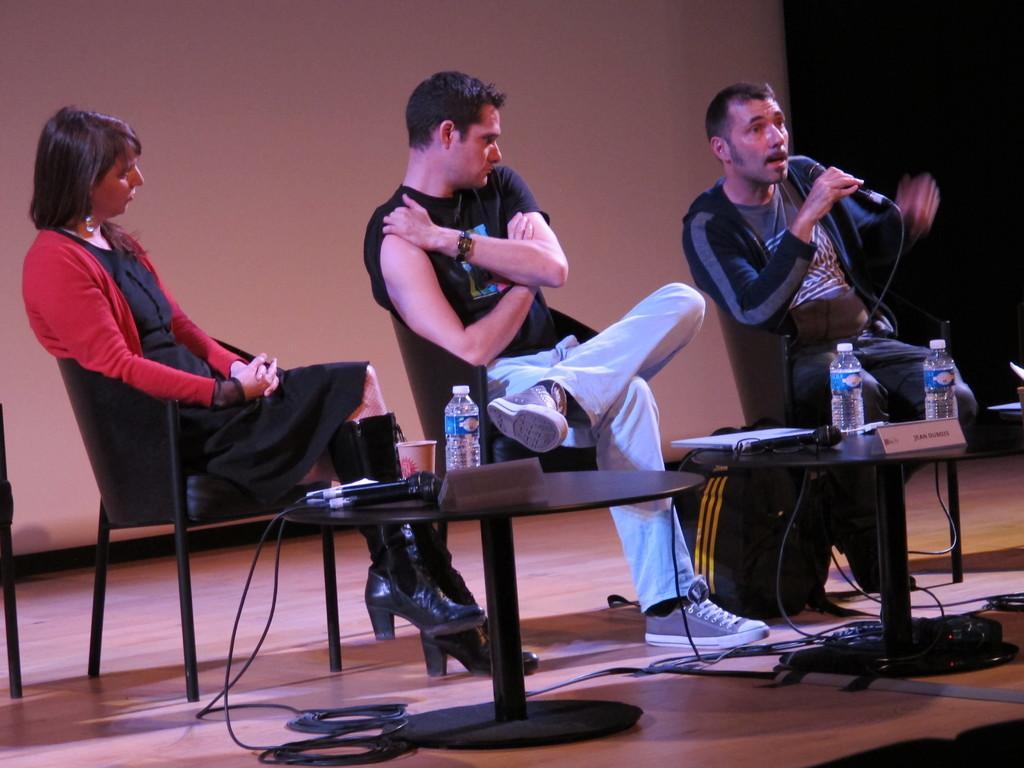Could you give a brief overview of what you see in this image? In this image there are three people sitting on the chairs, in front of them there is a table with mics, water bottles and some other objects on it. In the background there is a wall. 